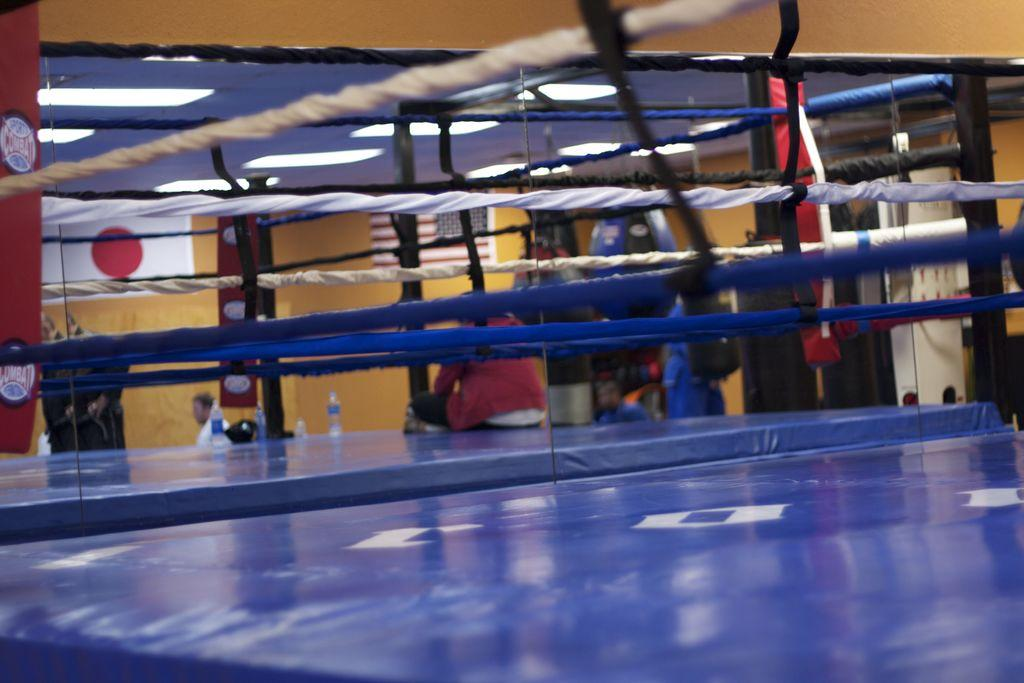What is the main feature in the center of the image? There is a boxing ring in the center of the image. What type of argument is taking place between the fighters in the boxing ring? There is no argument taking place in the boxing ring, as the image depicts a boxing match, not a verbal disagreement. 